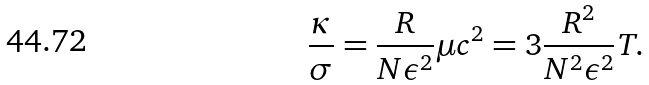<formula> <loc_0><loc_0><loc_500><loc_500>\frac { \kappa } { \sigma } = \frac { R } { N \epsilon ^ { 2 } } \mu c ^ { 2 } = 3 \frac { R ^ { 2 } } { N ^ { 2 } \epsilon ^ { 2 } } T .</formula> 